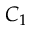<formula> <loc_0><loc_0><loc_500><loc_500>C _ { 1 }</formula> 